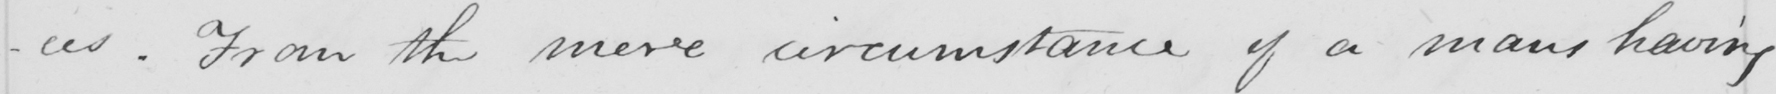Please transcribe the handwritten text in this image. From the mere circumstance of a man ' s having 